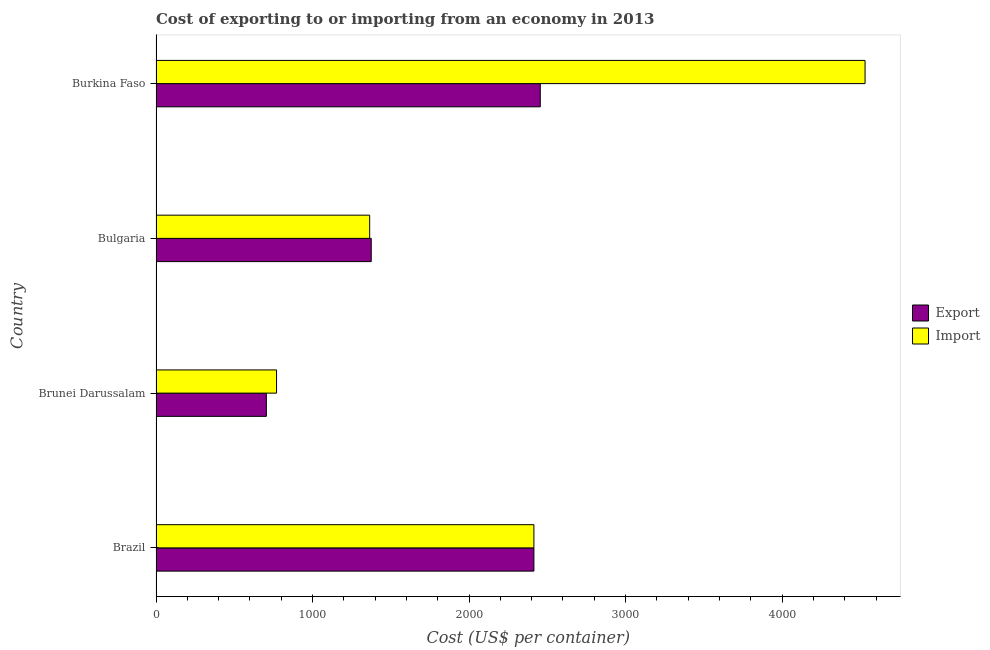How many groups of bars are there?
Your response must be concise. 4. Are the number of bars on each tick of the Y-axis equal?
Make the answer very short. Yes. How many bars are there on the 4th tick from the top?
Give a very brief answer. 2. What is the label of the 3rd group of bars from the top?
Provide a short and direct response. Brunei Darussalam. What is the export cost in Brazil?
Keep it short and to the point. 2414.3. Across all countries, what is the maximum import cost?
Offer a terse response. 4530. Across all countries, what is the minimum export cost?
Your response must be concise. 705. In which country was the export cost maximum?
Provide a short and direct response. Burkina Faso. In which country was the import cost minimum?
Your answer should be very brief. Brunei Darussalam. What is the total export cost in the graph?
Your answer should be compact. 6949.3. What is the difference between the import cost in Bulgaria and that in Burkina Faso?
Give a very brief answer. -3165. What is the difference between the export cost in Bulgaria and the import cost in Brazil?
Your response must be concise. -1039.3. What is the average export cost per country?
Ensure brevity in your answer.  1737.33. What is the ratio of the export cost in Bulgaria to that in Burkina Faso?
Give a very brief answer. 0.56. Is the export cost in Brunei Darussalam less than that in Bulgaria?
Provide a succinct answer. Yes. Is the difference between the export cost in Brazil and Bulgaria greater than the difference between the import cost in Brazil and Bulgaria?
Your answer should be very brief. No. What is the difference between the highest and the second highest export cost?
Your answer should be compact. 40.7. What is the difference between the highest and the lowest export cost?
Your answer should be compact. 1750. In how many countries, is the export cost greater than the average export cost taken over all countries?
Your answer should be very brief. 2. Is the sum of the export cost in Brazil and Bulgaria greater than the maximum import cost across all countries?
Ensure brevity in your answer.  No. What does the 2nd bar from the top in Brunei Darussalam represents?
Keep it short and to the point. Export. What does the 2nd bar from the bottom in Bulgaria represents?
Ensure brevity in your answer.  Import. Are all the bars in the graph horizontal?
Your answer should be very brief. Yes. How many countries are there in the graph?
Your response must be concise. 4. Are the values on the major ticks of X-axis written in scientific E-notation?
Give a very brief answer. No. Does the graph contain any zero values?
Your answer should be compact. No. Does the graph contain grids?
Provide a succinct answer. No. Where does the legend appear in the graph?
Your answer should be very brief. Center right. How are the legend labels stacked?
Your answer should be compact. Vertical. What is the title of the graph?
Provide a short and direct response. Cost of exporting to or importing from an economy in 2013. Does "Highest 20% of population" appear as one of the legend labels in the graph?
Make the answer very short. No. What is the label or title of the X-axis?
Offer a very short reply. Cost (US$ per container). What is the Cost (US$ per container) in Export in Brazil?
Your answer should be compact. 2414.3. What is the Cost (US$ per container) of Import in Brazil?
Offer a very short reply. 2414.3. What is the Cost (US$ per container) of Export in Brunei Darussalam?
Ensure brevity in your answer.  705. What is the Cost (US$ per container) of Import in Brunei Darussalam?
Your answer should be very brief. 770. What is the Cost (US$ per container) of Export in Bulgaria?
Give a very brief answer. 1375. What is the Cost (US$ per container) of Import in Bulgaria?
Your response must be concise. 1365. What is the Cost (US$ per container) in Export in Burkina Faso?
Provide a succinct answer. 2455. What is the Cost (US$ per container) of Import in Burkina Faso?
Give a very brief answer. 4530. Across all countries, what is the maximum Cost (US$ per container) of Export?
Your answer should be very brief. 2455. Across all countries, what is the maximum Cost (US$ per container) in Import?
Offer a very short reply. 4530. Across all countries, what is the minimum Cost (US$ per container) in Export?
Offer a terse response. 705. Across all countries, what is the minimum Cost (US$ per container) of Import?
Your response must be concise. 770. What is the total Cost (US$ per container) in Export in the graph?
Your answer should be compact. 6949.3. What is the total Cost (US$ per container) of Import in the graph?
Keep it short and to the point. 9079.3. What is the difference between the Cost (US$ per container) in Export in Brazil and that in Brunei Darussalam?
Your answer should be very brief. 1709.3. What is the difference between the Cost (US$ per container) of Import in Brazil and that in Brunei Darussalam?
Offer a very short reply. 1644.3. What is the difference between the Cost (US$ per container) in Export in Brazil and that in Bulgaria?
Your answer should be very brief. 1039.3. What is the difference between the Cost (US$ per container) of Import in Brazil and that in Bulgaria?
Offer a terse response. 1049.3. What is the difference between the Cost (US$ per container) in Export in Brazil and that in Burkina Faso?
Provide a succinct answer. -40.7. What is the difference between the Cost (US$ per container) in Import in Brazil and that in Burkina Faso?
Ensure brevity in your answer.  -2115.7. What is the difference between the Cost (US$ per container) of Export in Brunei Darussalam and that in Bulgaria?
Give a very brief answer. -670. What is the difference between the Cost (US$ per container) in Import in Brunei Darussalam and that in Bulgaria?
Your response must be concise. -595. What is the difference between the Cost (US$ per container) of Export in Brunei Darussalam and that in Burkina Faso?
Keep it short and to the point. -1750. What is the difference between the Cost (US$ per container) in Import in Brunei Darussalam and that in Burkina Faso?
Your response must be concise. -3760. What is the difference between the Cost (US$ per container) of Export in Bulgaria and that in Burkina Faso?
Offer a very short reply. -1080. What is the difference between the Cost (US$ per container) in Import in Bulgaria and that in Burkina Faso?
Give a very brief answer. -3165. What is the difference between the Cost (US$ per container) in Export in Brazil and the Cost (US$ per container) in Import in Brunei Darussalam?
Your answer should be very brief. 1644.3. What is the difference between the Cost (US$ per container) of Export in Brazil and the Cost (US$ per container) of Import in Bulgaria?
Provide a short and direct response. 1049.3. What is the difference between the Cost (US$ per container) of Export in Brazil and the Cost (US$ per container) of Import in Burkina Faso?
Provide a short and direct response. -2115.7. What is the difference between the Cost (US$ per container) of Export in Brunei Darussalam and the Cost (US$ per container) of Import in Bulgaria?
Your answer should be very brief. -660. What is the difference between the Cost (US$ per container) of Export in Brunei Darussalam and the Cost (US$ per container) of Import in Burkina Faso?
Provide a short and direct response. -3825. What is the difference between the Cost (US$ per container) of Export in Bulgaria and the Cost (US$ per container) of Import in Burkina Faso?
Provide a succinct answer. -3155. What is the average Cost (US$ per container) in Export per country?
Provide a short and direct response. 1737.33. What is the average Cost (US$ per container) in Import per country?
Make the answer very short. 2269.82. What is the difference between the Cost (US$ per container) in Export and Cost (US$ per container) in Import in Brunei Darussalam?
Make the answer very short. -65. What is the difference between the Cost (US$ per container) of Export and Cost (US$ per container) of Import in Burkina Faso?
Your answer should be very brief. -2075. What is the ratio of the Cost (US$ per container) of Export in Brazil to that in Brunei Darussalam?
Your answer should be compact. 3.42. What is the ratio of the Cost (US$ per container) in Import in Brazil to that in Brunei Darussalam?
Give a very brief answer. 3.14. What is the ratio of the Cost (US$ per container) in Export in Brazil to that in Bulgaria?
Your answer should be very brief. 1.76. What is the ratio of the Cost (US$ per container) in Import in Brazil to that in Bulgaria?
Ensure brevity in your answer.  1.77. What is the ratio of the Cost (US$ per container) in Export in Brazil to that in Burkina Faso?
Offer a very short reply. 0.98. What is the ratio of the Cost (US$ per container) in Import in Brazil to that in Burkina Faso?
Provide a short and direct response. 0.53. What is the ratio of the Cost (US$ per container) of Export in Brunei Darussalam to that in Bulgaria?
Offer a very short reply. 0.51. What is the ratio of the Cost (US$ per container) in Import in Brunei Darussalam to that in Bulgaria?
Your response must be concise. 0.56. What is the ratio of the Cost (US$ per container) in Export in Brunei Darussalam to that in Burkina Faso?
Ensure brevity in your answer.  0.29. What is the ratio of the Cost (US$ per container) in Import in Brunei Darussalam to that in Burkina Faso?
Your answer should be compact. 0.17. What is the ratio of the Cost (US$ per container) of Export in Bulgaria to that in Burkina Faso?
Make the answer very short. 0.56. What is the ratio of the Cost (US$ per container) of Import in Bulgaria to that in Burkina Faso?
Your answer should be compact. 0.3. What is the difference between the highest and the second highest Cost (US$ per container) in Export?
Keep it short and to the point. 40.7. What is the difference between the highest and the second highest Cost (US$ per container) in Import?
Give a very brief answer. 2115.7. What is the difference between the highest and the lowest Cost (US$ per container) of Export?
Ensure brevity in your answer.  1750. What is the difference between the highest and the lowest Cost (US$ per container) in Import?
Provide a short and direct response. 3760. 